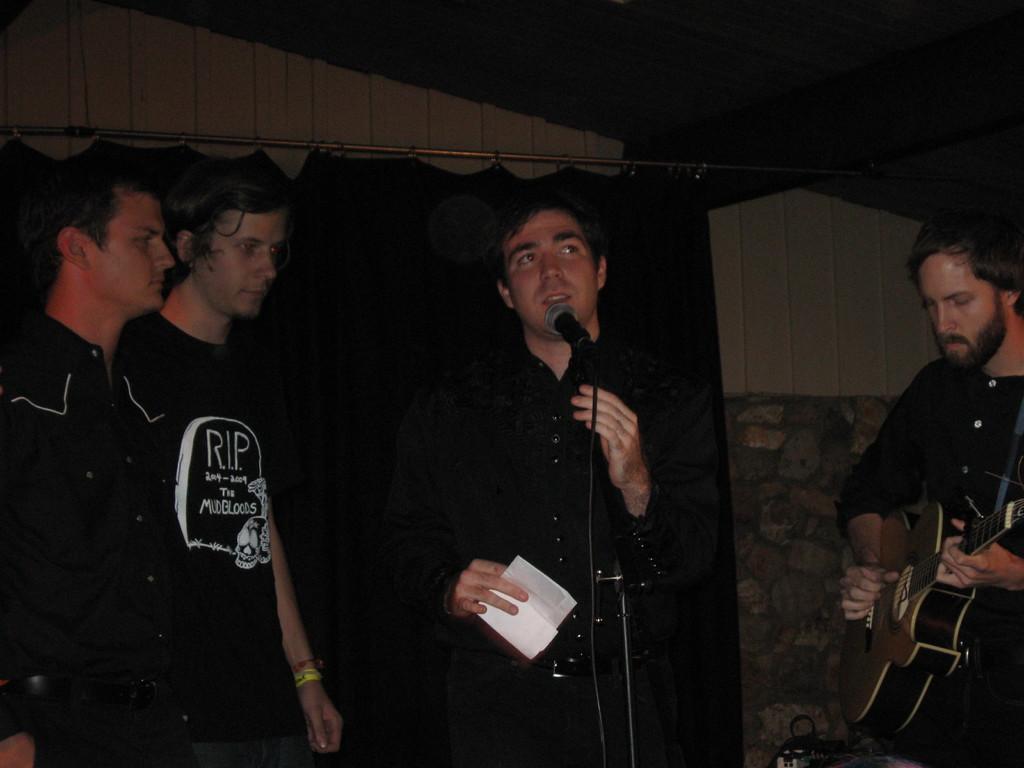Can you describe this image briefly? In this picture we can see four persons. in the middle we can see a man standing in front of a mike and singing by holding a paper in his hand. At the right side of a picture we can see one man playing a guitar. 